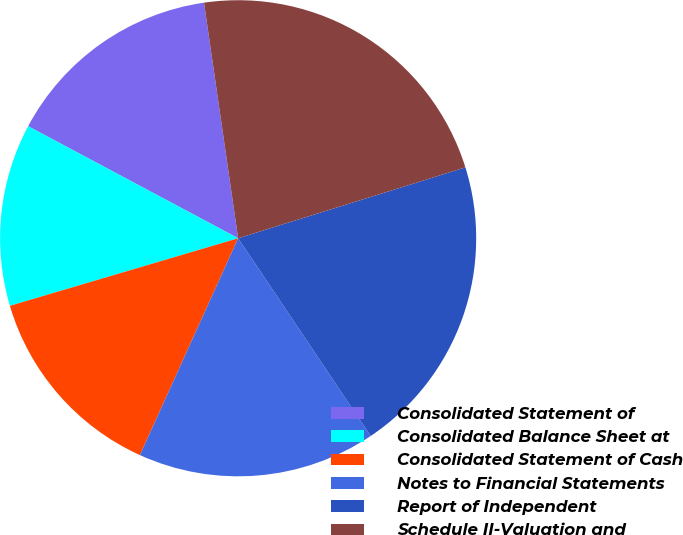<chart> <loc_0><loc_0><loc_500><loc_500><pie_chart><fcel>Consolidated Statement of<fcel>Consolidated Balance Sheet at<fcel>Consolidated Statement of Cash<fcel>Notes to Financial Statements<fcel>Report of Independent<fcel>Schedule II-Valuation and<nl><fcel>14.91%<fcel>12.38%<fcel>13.65%<fcel>16.17%<fcel>20.41%<fcel>22.48%<nl></chart> 